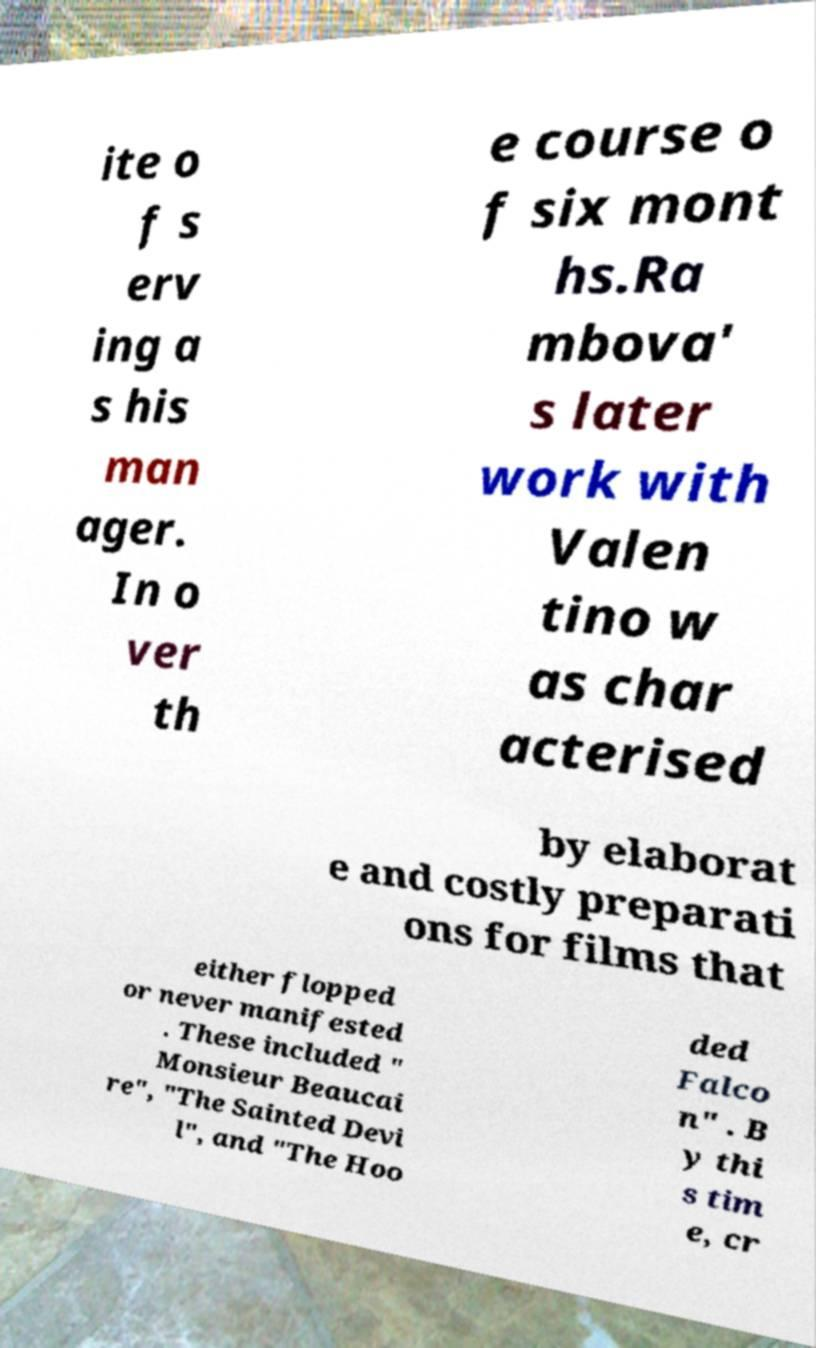There's text embedded in this image that I need extracted. Can you transcribe it verbatim? ite o f s erv ing a s his man ager. In o ver th e course o f six mont hs.Ra mbova' s later work with Valen tino w as char acterised by elaborat e and costly preparati ons for films that either flopped or never manifested . These included " Monsieur Beaucai re", "The Sainted Devi l", and "The Hoo ded Falco n" . B y thi s tim e, cr 